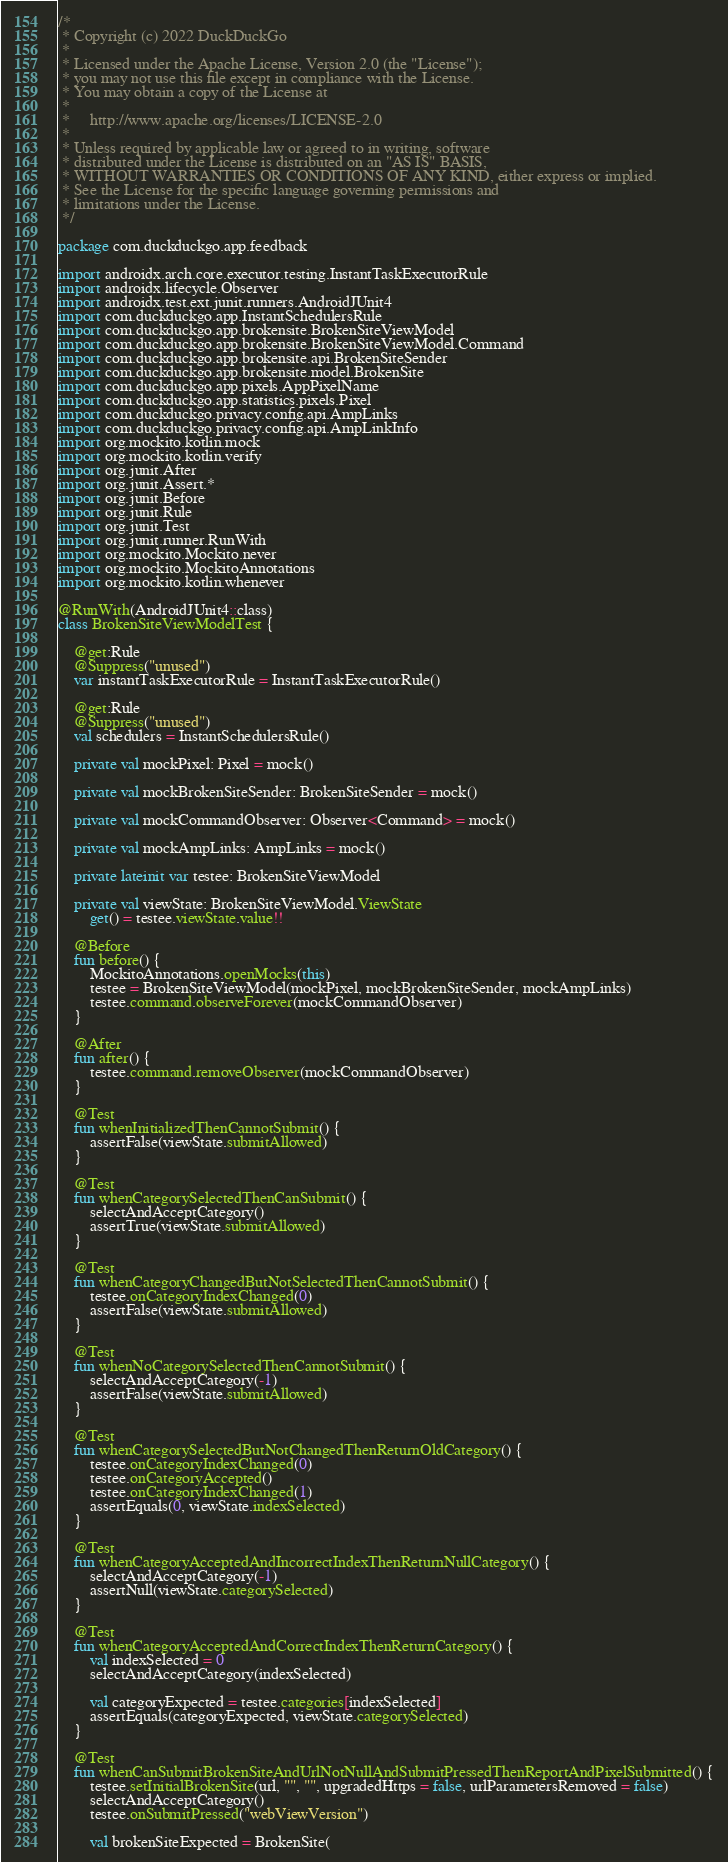Convert code to text. <code><loc_0><loc_0><loc_500><loc_500><_Kotlin_>/*
 * Copyright (c) 2022 DuckDuckGo
 *
 * Licensed under the Apache License, Version 2.0 (the "License");
 * you may not use this file except in compliance with the License.
 * You may obtain a copy of the License at
 *
 *     http://www.apache.org/licenses/LICENSE-2.0
 *
 * Unless required by applicable law or agreed to in writing, software
 * distributed under the License is distributed on an "AS IS" BASIS,
 * WITHOUT WARRANTIES OR CONDITIONS OF ANY KIND, either express or implied.
 * See the License for the specific language governing permissions and
 * limitations under the License.
 */

package com.duckduckgo.app.feedback

import androidx.arch.core.executor.testing.InstantTaskExecutorRule
import androidx.lifecycle.Observer
import androidx.test.ext.junit.runners.AndroidJUnit4
import com.duckduckgo.app.InstantSchedulersRule
import com.duckduckgo.app.brokensite.BrokenSiteViewModel
import com.duckduckgo.app.brokensite.BrokenSiteViewModel.Command
import com.duckduckgo.app.brokensite.api.BrokenSiteSender
import com.duckduckgo.app.brokensite.model.BrokenSite
import com.duckduckgo.app.pixels.AppPixelName
import com.duckduckgo.app.statistics.pixels.Pixel
import com.duckduckgo.privacy.config.api.AmpLinks
import com.duckduckgo.privacy.config.api.AmpLinkInfo
import org.mockito.kotlin.mock
import org.mockito.kotlin.verify
import org.junit.After
import org.junit.Assert.*
import org.junit.Before
import org.junit.Rule
import org.junit.Test
import org.junit.runner.RunWith
import org.mockito.Mockito.never
import org.mockito.MockitoAnnotations
import org.mockito.kotlin.whenever

@RunWith(AndroidJUnit4::class)
class BrokenSiteViewModelTest {

    @get:Rule
    @Suppress("unused")
    var instantTaskExecutorRule = InstantTaskExecutorRule()

    @get:Rule
    @Suppress("unused")
    val schedulers = InstantSchedulersRule()

    private val mockPixel: Pixel = mock()

    private val mockBrokenSiteSender: BrokenSiteSender = mock()

    private val mockCommandObserver: Observer<Command> = mock()

    private val mockAmpLinks: AmpLinks = mock()

    private lateinit var testee: BrokenSiteViewModel

    private val viewState: BrokenSiteViewModel.ViewState
        get() = testee.viewState.value!!

    @Before
    fun before() {
        MockitoAnnotations.openMocks(this)
        testee = BrokenSiteViewModel(mockPixel, mockBrokenSiteSender, mockAmpLinks)
        testee.command.observeForever(mockCommandObserver)
    }

    @After
    fun after() {
        testee.command.removeObserver(mockCommandObserver)
    }

    @Test
    fun whenInitializedThenCannotSubmit() {
        assertFalse(viewState.submitAllowed)
    }

    @Test
    fun whenCategorySelectedThenCanSubmit() {
        selectAndAcceptCategory()
        assertTrue(viewState.submitAllowed)
    }

    @Test
    fun whenCategoryChangedButNotSelectedThenCannotSubmit() {
        testee.onCategoryIndexChanged(0)
        assertFalse(viewState.submitAllowed)
    }

    @Test
    fun whenNoCategorySelectedThenCannotSubmit() {
        selectAndAcceptCategory(-1)
        assertFalse(viewState.submitAllowed)
    }

    @Test
    fun whenCategorySelectedButNotChangedThenReturnOldCategory() {
        testee.onCategoryIndexChanged(0)
        testee.onCategoryAccepted()
        testee.onCategoryIndexChanged(1)
        assertEquals(0, viewState.indexSelected)
    }

    @Test
    fun whenCategoryAcceptedAndIncorrectIndexThenReturnNullCategory() {
        selectAndAcceptCategory(-1)
        assertNull(viewState.categorySelected)
    }

    @Test
    fun whenCategoryAcceptedAndCorrectIndexThenReturnCategory() {
        val indexSelected = 0
        selectAndAcceptCategory(indexSelected)

        val categoryExpected = testee.categories[indexSelected]
        assertEquals(categoryExpected, viewState.categorySelected)
    }

    @Test
    fun whenCanSubmitBrokenSiteAndUrlNotNullAndSubmitPressedThenReportAndPixelSubmitted() {
        testee.setInitialBrokenSite(url, "", "", upgradedHttps = false, urlParametersRemoved = false)
        selectAndAcceptCategory()
        testee.onSubmitPressed("webViewVersion")

        val brokenSiteExpected = BrokenSite(</code> 